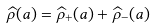Convert formula to latex. <formula><loc_0><loc_0><loc_500><loc_500>\widehat { \rho } ( a ) = \widehat { \rho } _ { + } ( a ) + \widehat { \rho } _ { - } ( a )</formula> 